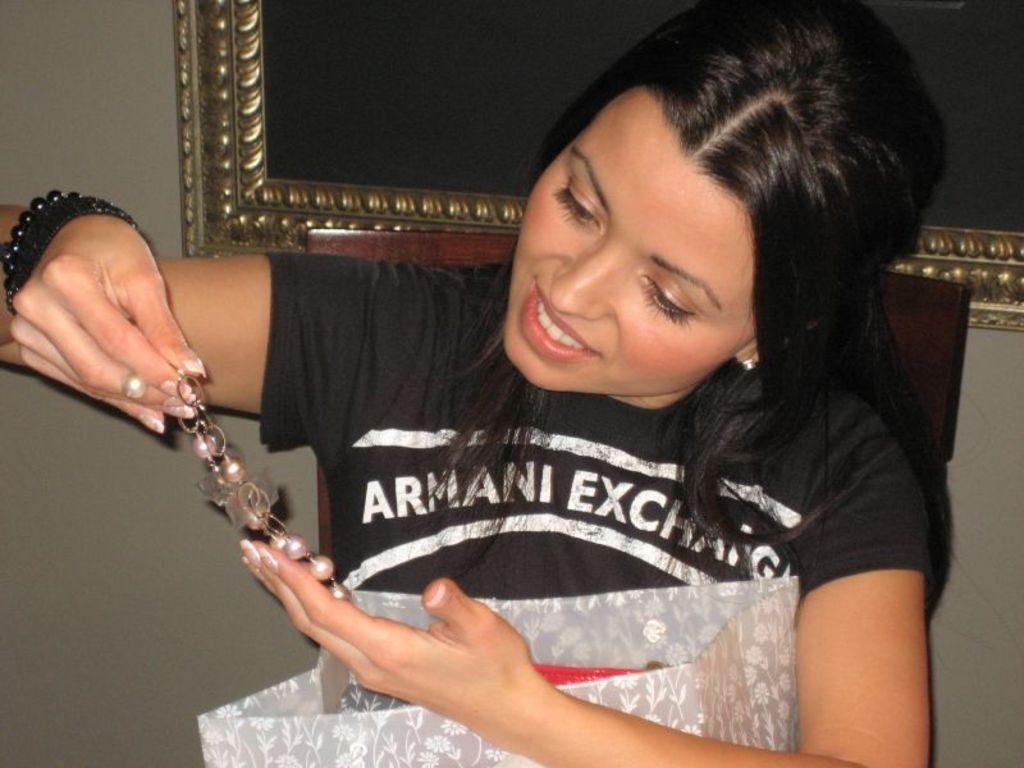In one or two sentences, can you explain what this image depicts? In this image we can see a girl sitting on a chair holding a cover and an object in her hands, in the background there is a frame attached to the wall. 